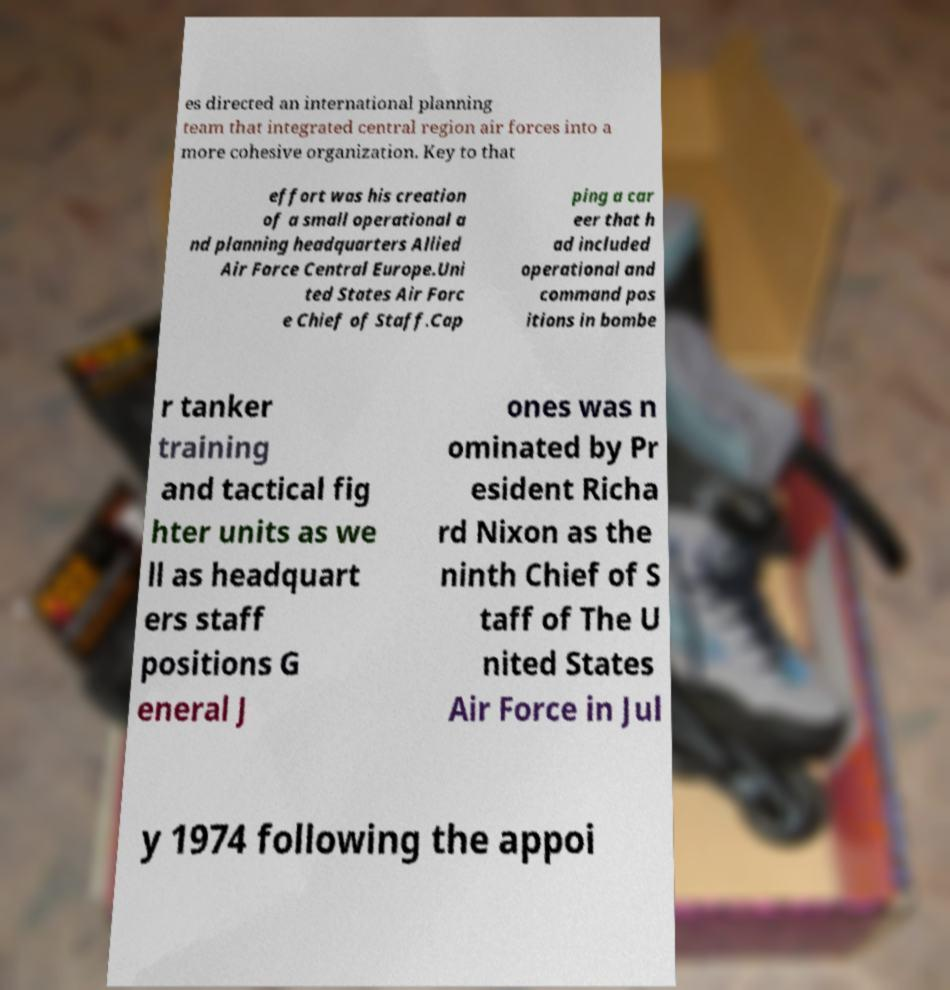Could you extract and type out the text from this image? es directed an international planning team that integrated central region air forces into a more cohesive organization. Key to that effort was his creation of a small operational a nd planning headquarters Allied Air Force Central Europe.Uni ted States Air Forc e Chief of Staff.Cap ping a car eer that h ad included operational and command pos itions in bombe r tanker training and tactical fig hter units as we ll as headquart ers staff positions G eneral J ones was n ominated by Pr esident Richa rd Nixon as the ninth Chief of S taff of The U nited States Air Force in Jul y 1974 following the appoi 